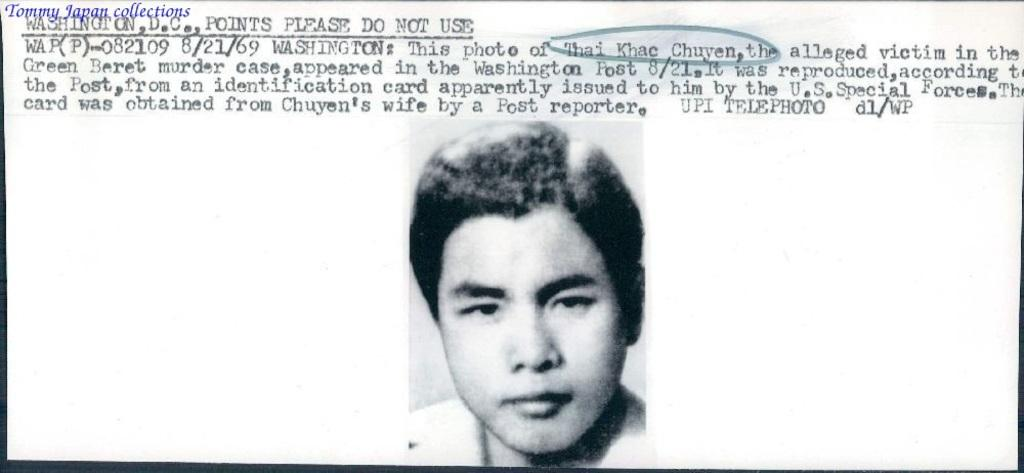What type of picture is in the image? The image contains a black and white picture of a person. What color are the words written on the top of the image? The words written on the top of the image are black. What color is the background of the image? The background of the image is white. What type of calendar is shown in the image? There is no calendar present in the image. What nation is represented by the person in the image? The image does not provide any information about the person's nationality, so it cannot be determined from the image. 